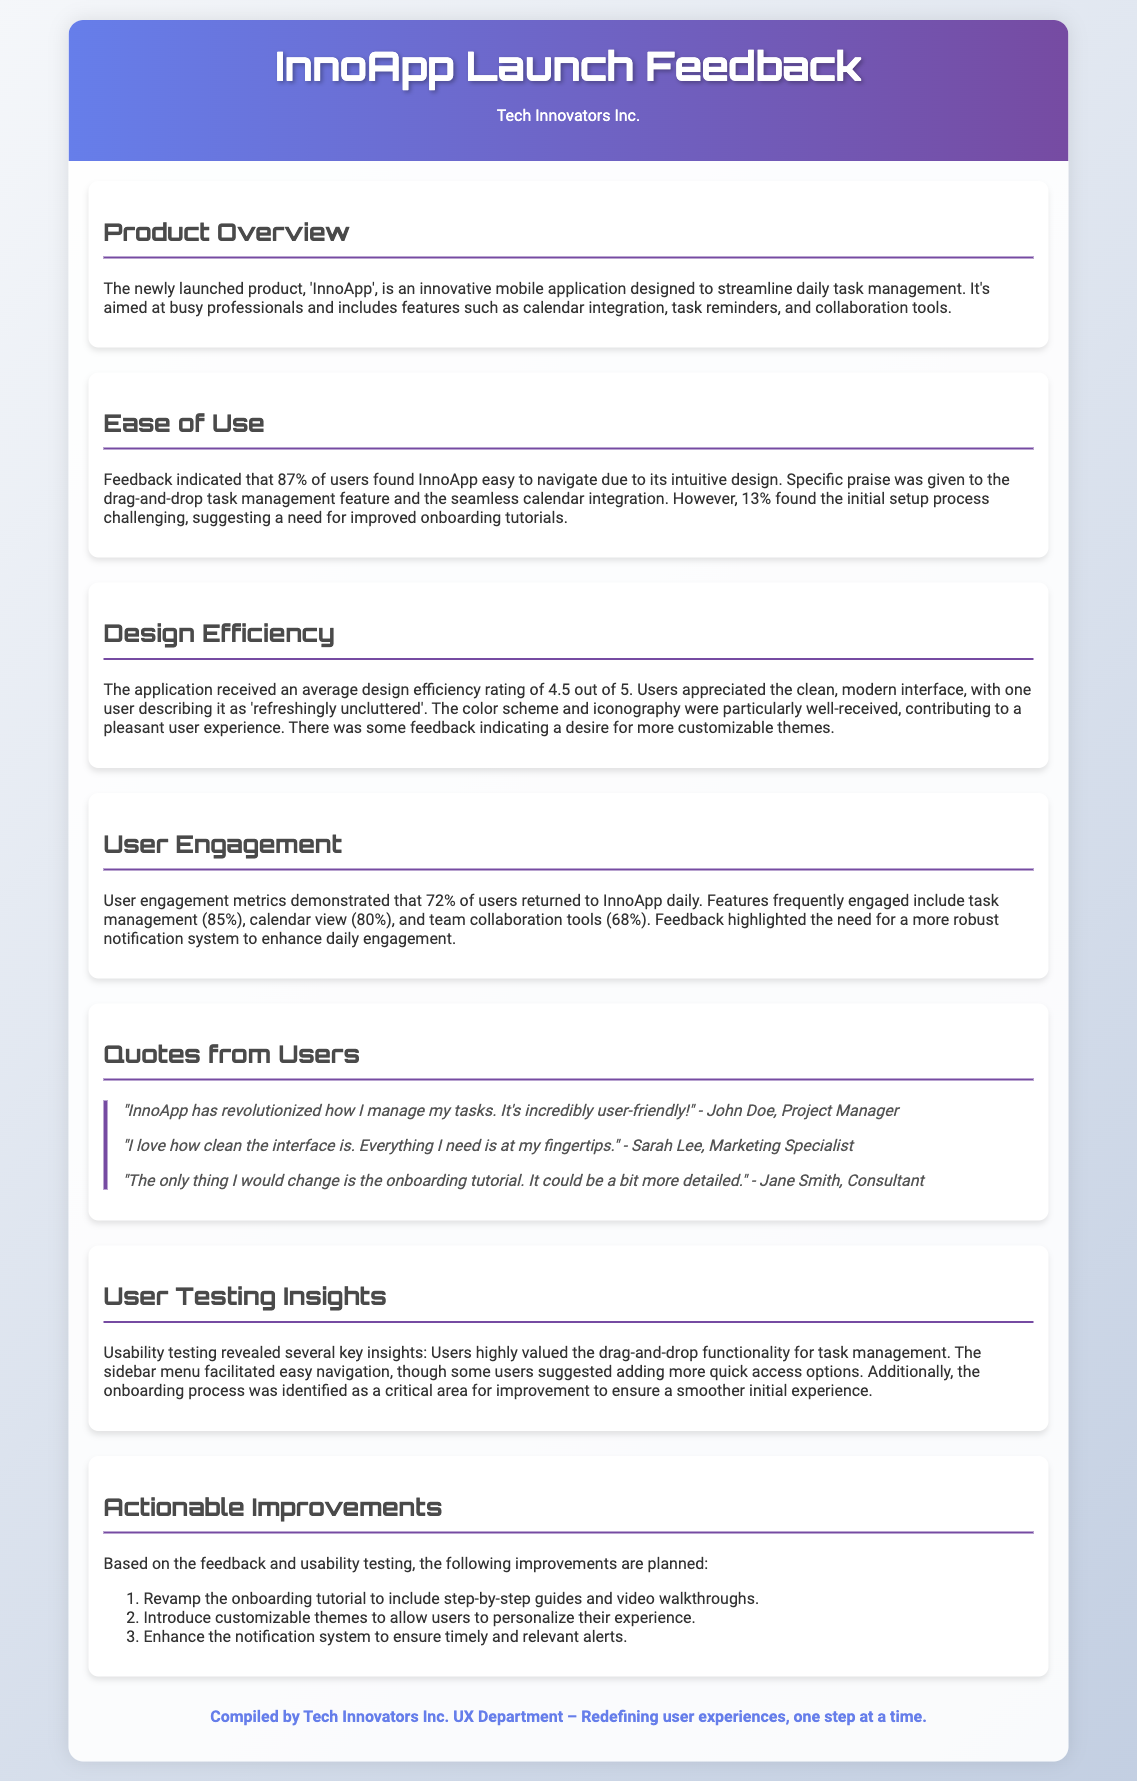What is the name of the new product? The document mentions that the new product is called 'InnoApp'.
Answer: InnoApp What percentage of users found InnoApp easy to navigate? The feedback indicates that 87% of users found InnoApp easy to navigate.
Answer: 87% What is the average design efficiency rating for the application? According to the document, the average design efficiency rating is 4.5 out of 5.
Answer: 4.5 out of 5 Which feature had the highest user engagement percentage? The document states that task management had a user engagement percentage of 85%, which is the highest among the features mentioned.
Answer: 85% What improvement is suggested for the onboarding tutorial? Users suggested that the onboarding tutorial could be more detailed.
Answer: More detailed 